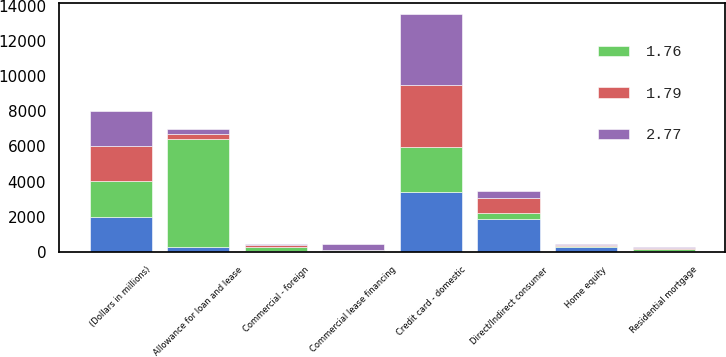<chart> <loc_0><loc_0><loc_500><loc_500><stacked_bar_chart><ecel><fcel>(Dollars in millions)<fcel>Allowance for loan and lease<fcel>Residential mortgage<fcel>Credit card - domestic<fcel>Home equity<fcel>Direct/Indirect consumer<fcel>Commercial lease financing<fcel>Commercial - foreign<nl><fcel>nan<fcel>2007<fcel>286<fcel>79<fcel>3410<fcel>286<fcel>1885<fcel>55<fcel>28<nl><fcel>1.79<fcel>2006<fcel>286<fcel>74<fcel>3546<fcel>67<fcel>857<fcel>28<fcel>86<nl><fcel>2.77<fcel>2005<fcel>286<fcel>58<fcel>4018<fcel>46<fcel>380<fcel>315<fcel>61<nl><fcel>1.76<fcel>2004<fcel>6163<fcel>62<fcel>2536<fcel>38<fcel>344<fcel>39<fcel>262<nl></chart> 